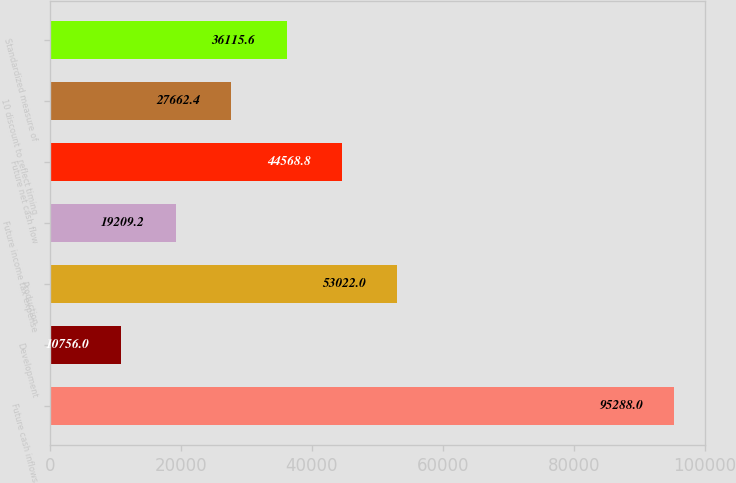<chart> <loc_0><loc_0><loc_500><loc_500><bar_chart><fcel>Future cash inflows<fcel>Development<fcel>Production<fcel>Future income tax expense<fcel>Future net cash flow<fcel>10 discount to reflect timing<fcel>Standardized measure of<nl><fcel>95288<fcel>10756<fcel>53022<fcel>19209.2<fcel>44568.8<fcel>27662.4<fcel>36115.6<nl></chart> 